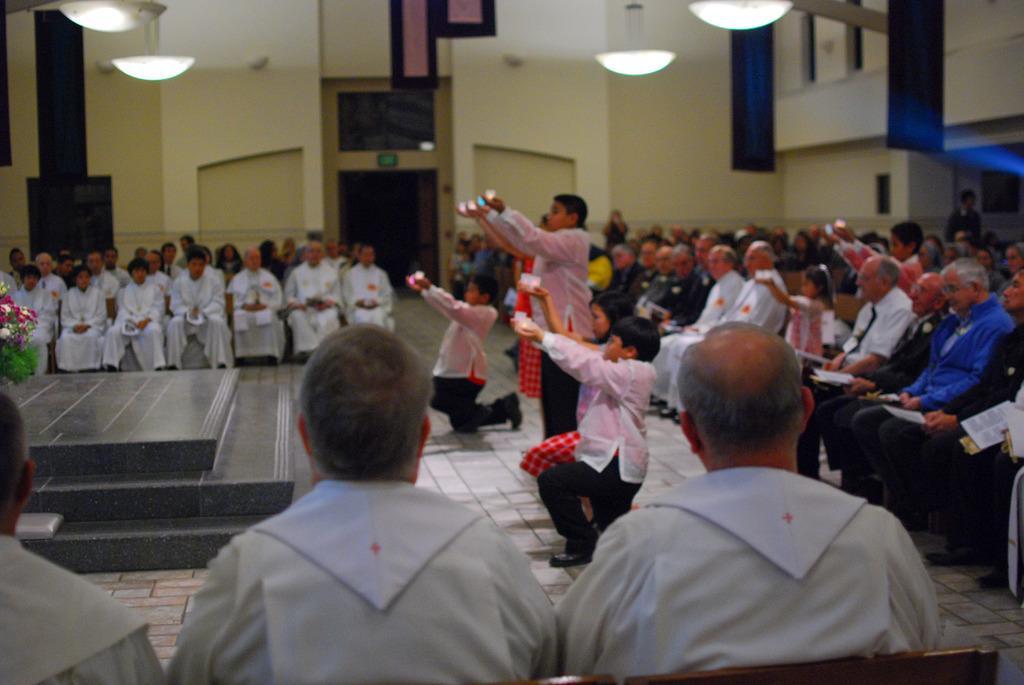Could you give a brief overview of what you see in this image? In this picture, we see many people are sitting on the chairs. At the bottom, we see three men are sitting on the chairs. In front of them, we see five children are performing and they are holding some objects in their hands. It looks like the candles. On the left side, we see the stairs and a flower bouquet. Behind that, we see the people are sitting on the chairs. Behind them, we see the pillars, a white wall and the entrance. On the right side, we see a man is standing. Behind him, we see a wall. At the top, we see the lights and the ceiling of the room. This picture might be clicked in the church. 